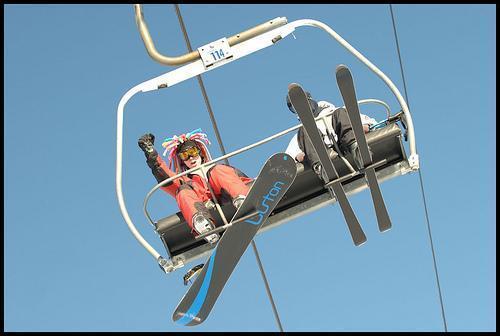How many are on the ski lift?
Give a very brief answer. 2. How many people can be seen?
Give a very brief answer. 2. How many ski can you see?
Give a very brief answer. 1. 